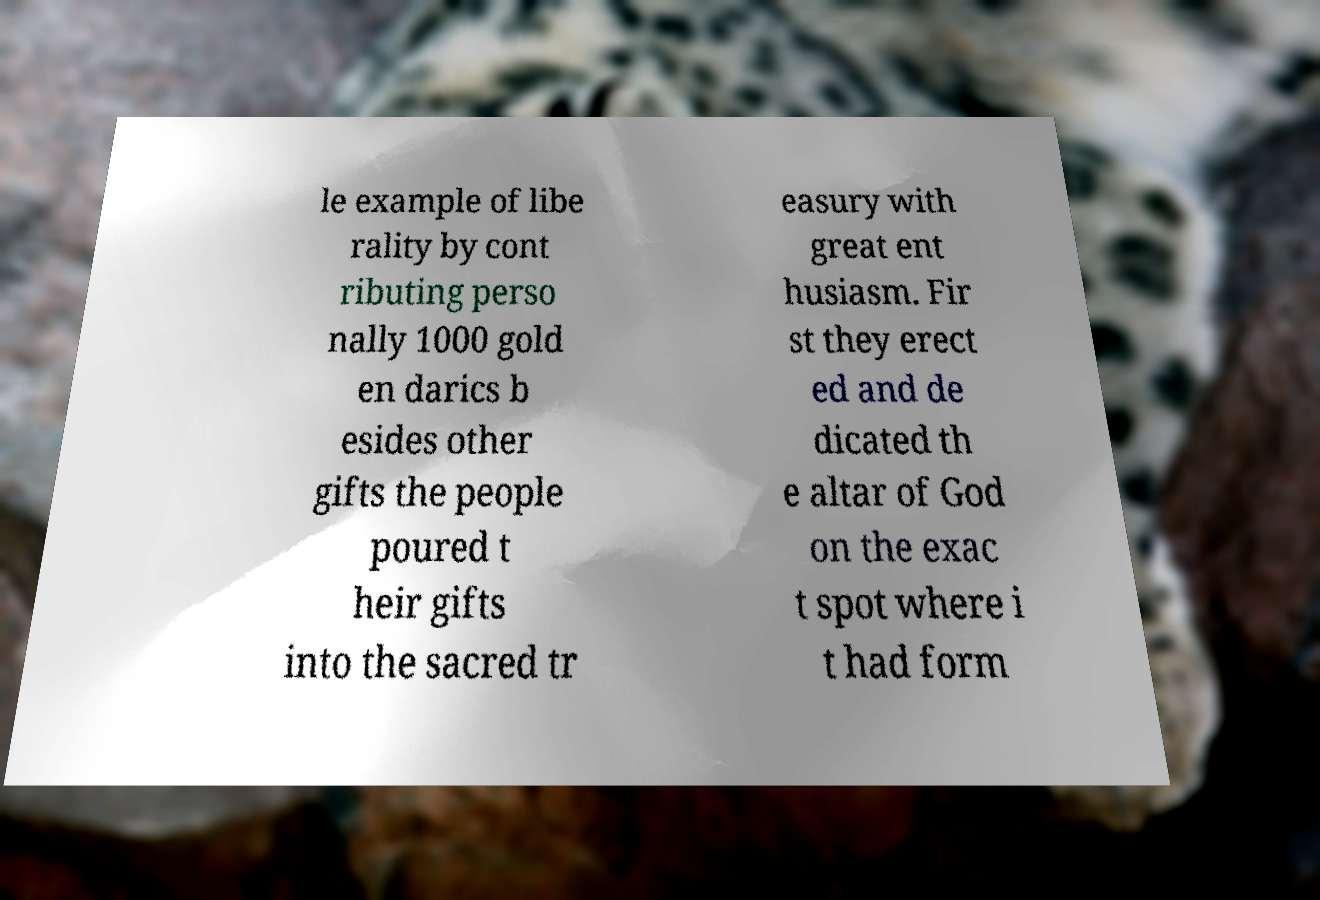There's text embedded in this image that I need extracted. Can you transcribe it verbatim? le example of libe rality by cont ributing perso nally 1000 gold en darics b esides other gifts the people poured t heir gifts into the sacred tr easury with great ent husiasm. Fir st they erect ed and de dicated th e altar of God on the exac t spot where i t had form 